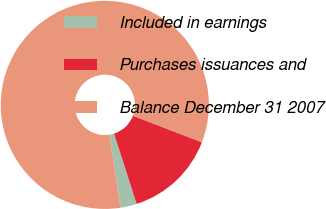<chart> <loc_0><loc_0><loc_500><loc_500><pie_chart><fcel>Included in earnings<fcel>Purchases issuances and<fcel>Balance December 31 2007<nl><fcel>2.54%<fcel>14.2%<fcel>83.26%<nl></chart> 